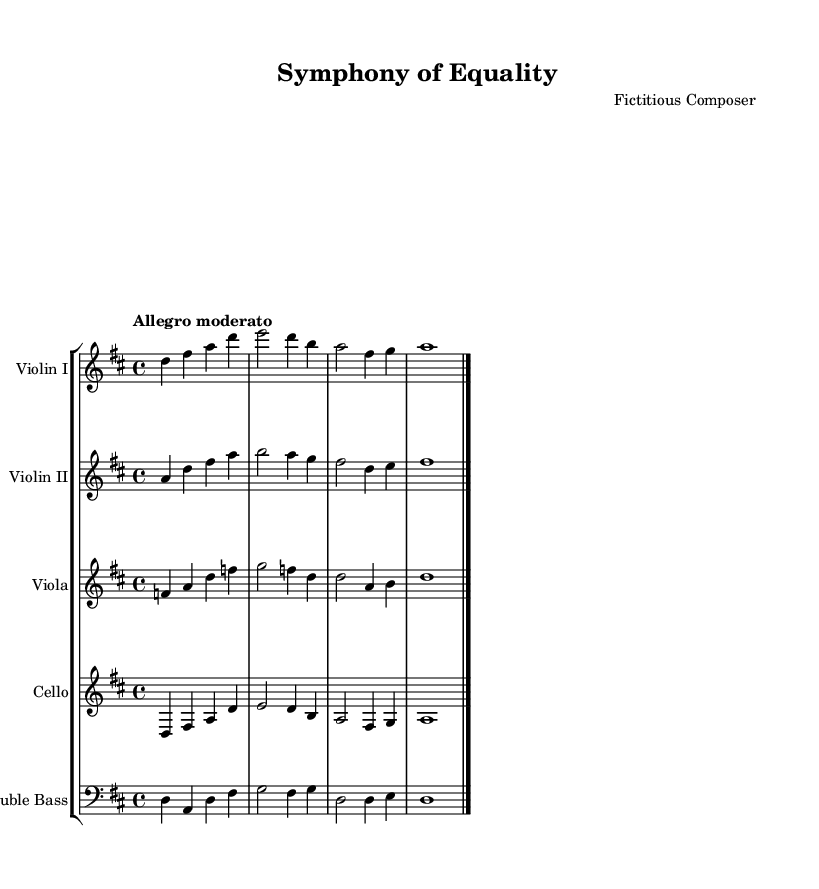What is the key signature of this music? The key signature is D major, indicated by the presence of sharp symbols on the F and C notes. This means that F# and C# are used throughout the piece.
Answer: D major What is the time signature of this piece? The time signature is 4/4, shown at the beginning of the score. This indicates that there are four beats in each measure, and the quarter note gets one beat.
Answer: 4/4 What tempo marking is used in this symphony? The tempo marking indicates "Allegro moderato," which suggests a moderately fast pace. This can be found at the beginning of the score, setting the character of the piece.
Answer: Allegro moderato How many instruments are featured in this composition? The piece features five instruments: two violins, one viola, one cello, and one double bass. This is clear from the staff groupings in the score.
Answer: Five What is the final bar line type used in the music? The final bar line is a double bar line, indicated by two vertical lines at the end of the last measure, which signifies the conclusion of the piece.
Answer: Double bar line In which major scale does the cello part start? The cello part starts on the note D, which is the tonic or root of the D major scale. This can be identified as the first note of the cello staff in the score.
Answer: D major 